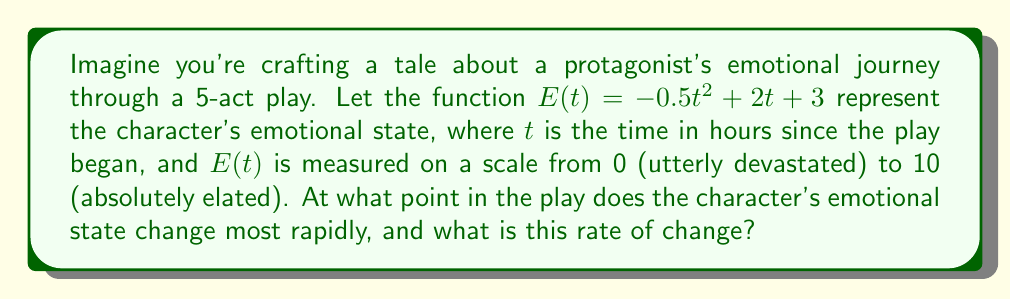Give your solution to this math problem. To solve this problem, we need to follow these steps:

1) The rate of change of the character's emotional state is represented by the derivative of $E(t)$. Let's find $E'(t)$:

   $$E'(t) = \frac{d}{dt}(-0.5t^2 + 2t + 3) = -t + 2$$

2) The rate of change is most rapid at the point where the second derivative equals zero. Let's find $E''(t)$:

   $$E''(t) = \frac{d}{dt}(-t + 2) = -1$$

3) Since $E''(t)$ is a constant (-1), it's never zero. This means the rate of change is always changing at a constant rate.

4) The maximum rate of change will occur at either the beginning or end of the play, depending on whether the rate is increasing or decreasing.

5) We can determine this by looking at $E'(t)$:
   - At $t=0$ (start of play): $E'(0) = 2$
   - At $t=5$ (end of play): $E'(5) = -3$

6) The absolute value of the rate of change is larger at the end of the play.

Therefore, the character's emotional state changes most rapidly at the end of the play (t = 5 hours).

The rate of change at this point is:

$$E'(5) = -(5) + 2 = -3$$

The negative value indicates the emotional state is decreasing rapidly.
Answer: The character's emotional state changes most rapidly at the end of the play (t = 5 hours) with a rate of change of -3 units per hour. 